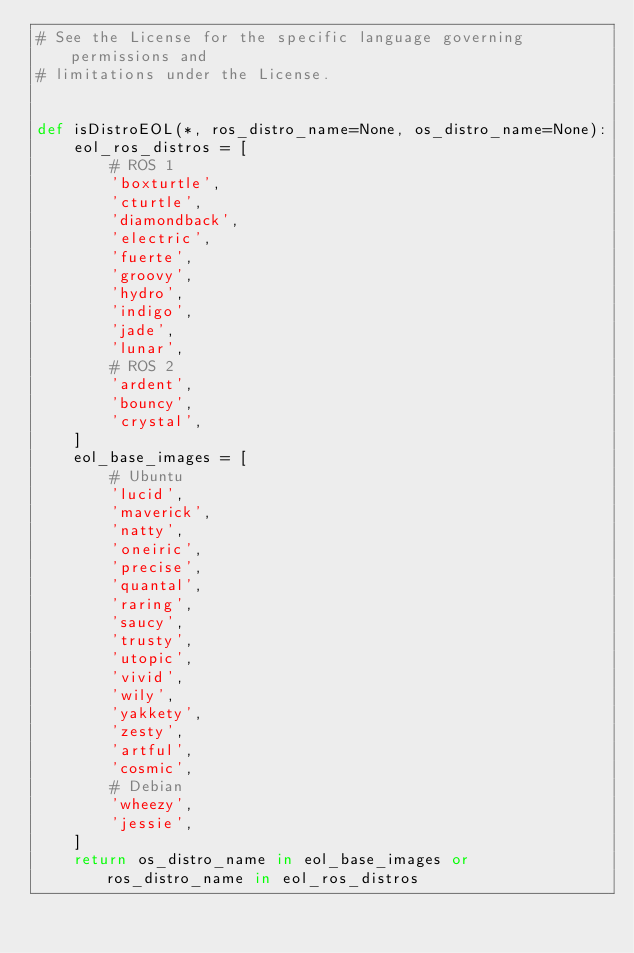Convert code to text. <code><loc_0><loc_0><loc_500><loc_500><_Python_># See the License for the specific language governing permissions and
# limitations under the License.


def isDistroEOL(*, ros_distro_name=None, os_distro_name=None):
    eol_ros_distros = [
        # ROS 1
        'boxturtle',
        'cturtle',
        'diamondback',
        'electric',
        'fuerte',
        'groovy',
        'hydro',
        'indigo',
        'jade',
        'lunar',
        # ROS 2
        'ardent',
        'bouncy',
        'crystal',
    ]
    eol_base_images = [
        # Ubuntu
        'lucid',
        'maverick',
        'natty',
        'oneiric',
        'precise',
        'quantal',
        'raring',
        'saucy',
        'trusty',
        'utopic',
        'vivid',
        'wily',
        'yakkety',
        'zesty',
        'artful',
        'cosmic',
        # Debian
        'wheezy',
        'jessie',
    ]
    return os_distro_name in eol_base_images or ros_distro_name in eol_ros_distros
</code> 